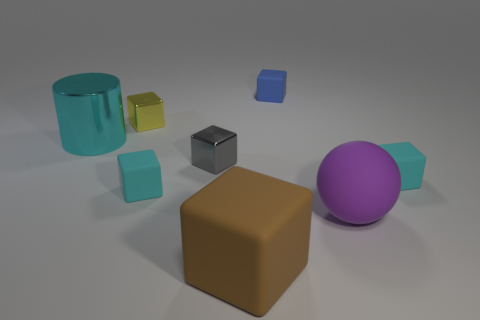Subtract all yellow blocks. How many blocks are left? 5 Subtract all brown blocks. How many blocks are left? 5 Subtract all purple cubes. Subtract all blue spheres. How many cubes are left? 6 Add 2 purple cylinders. How many objects exist? 10 Subtract all blocks. How many objects are left? 2 Add 1 brown objects. How many brown objects exist? 2 Subtract 0 gray spheres. How many objects are left? 8 Subtract all big brown rubber things. Subtract all yellow things. How many objects are left? 6 Add 4 small yellow cubes. How many small yellow cubes are left? 5 